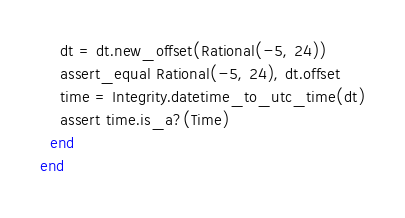Convert code to text. <code><loc_0><loc_0><loc_500><loc_500><_Ruby_>    dt = dt.new_offset(Rational(-5, 24))
    assert_equal Rational(-5, 24), dt.offset
    time = Integrity.datetime_to_utc_time(dt)
    assert time.is_a?(Time)
  end
end
</code> 